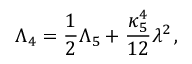<formula> <loc_0><loc_0><loc_500><loc_500>\Lambda _ { 4 } = { \frac { 1 } { 2 } } \Lambda _ { 5 } + { \frac { \kappa _ { 5 } ^ { 4 } } { 1 2 } } \lambda ^ { 2 } \, ,</formula> 